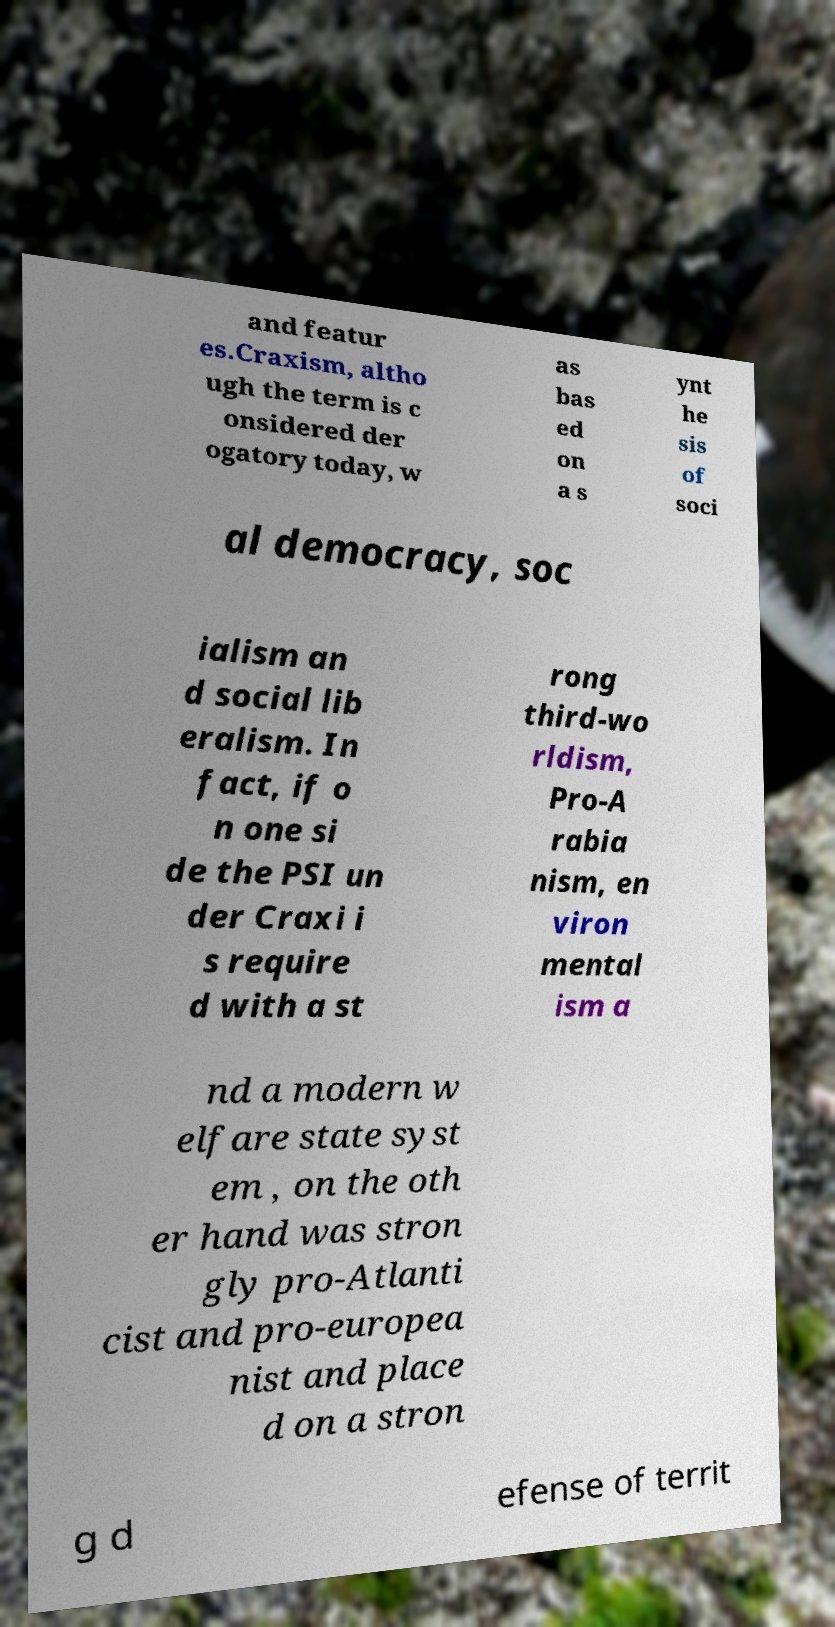Could you assist in decoding the text presented in this image and type it out clearly? and featur es.Craxism, altho ugh the term is c onsidered der ogatory today, w as bas ed on a s ynt he sis of soci al democracy, soc ialism an d social lib eralism. In fact, if o n one si de the PSI un der Craxi i s require d with a st rong third-wo rldism, Pro-A rabia nism, en viron mental ism a nd a modern w elfare state syst em , on the oth er hand was stron gly pro-Atlanti cist and pro-europea nist and place d on a stron g d efense of territ 